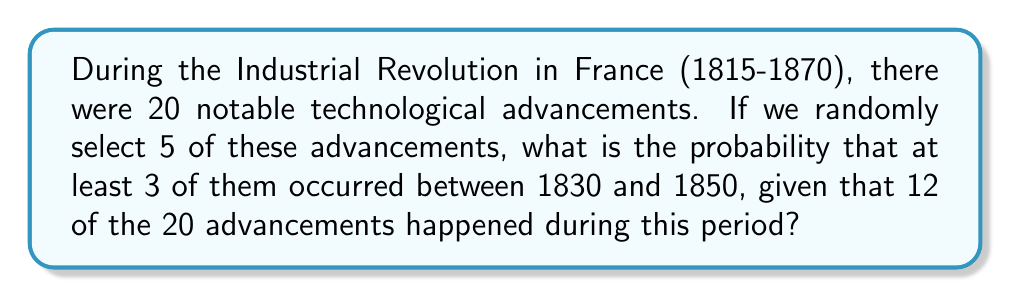Could you help me with this problem? Let's approach this step-by-step using combinatorics:

1) First, we need to calculate the total number of ways to select 5 advancements out of 20:
   $$\binom{20}{5} = \frac{20!}{5!(20-5)!} = 15,504$$

2) Now, we need to calculate the number of favorable outcomes. We can have:
   - 3 advancements from 1830-1850 and 2 from other periods
   - 4 advancements from 1830-1850 and 1 from other periods
   - 5 advancements from 1830-1850

3) Let's calculate each of these:
   - 3 from 1830-1850 and 2 from other periods:
     $$\binom{12}{3} \cdot \binom{8}{2} = 220 \cdot 28 = 6,160$$
   
   - 4 from 1830-1850 and 1 from other periods:
     $$\binom{12}{4} \cdot \binom{8}{1} = 495 \cdot 8 = 3,960$$
   
   - 5 from 1830-1850:
     $$\binom{12}{5} = 792$$

4) Total favorable outcomes:
   $$6,160 + 3,960 + 792 = 10,912$$

5) Probability:
   $$P(\text{at least 3 from 1830-1850}) = \frac{10,912}{15,504} = \frac{682}{969} \approx 0.7037$$
Answer: $\frac{682}{969}$ 